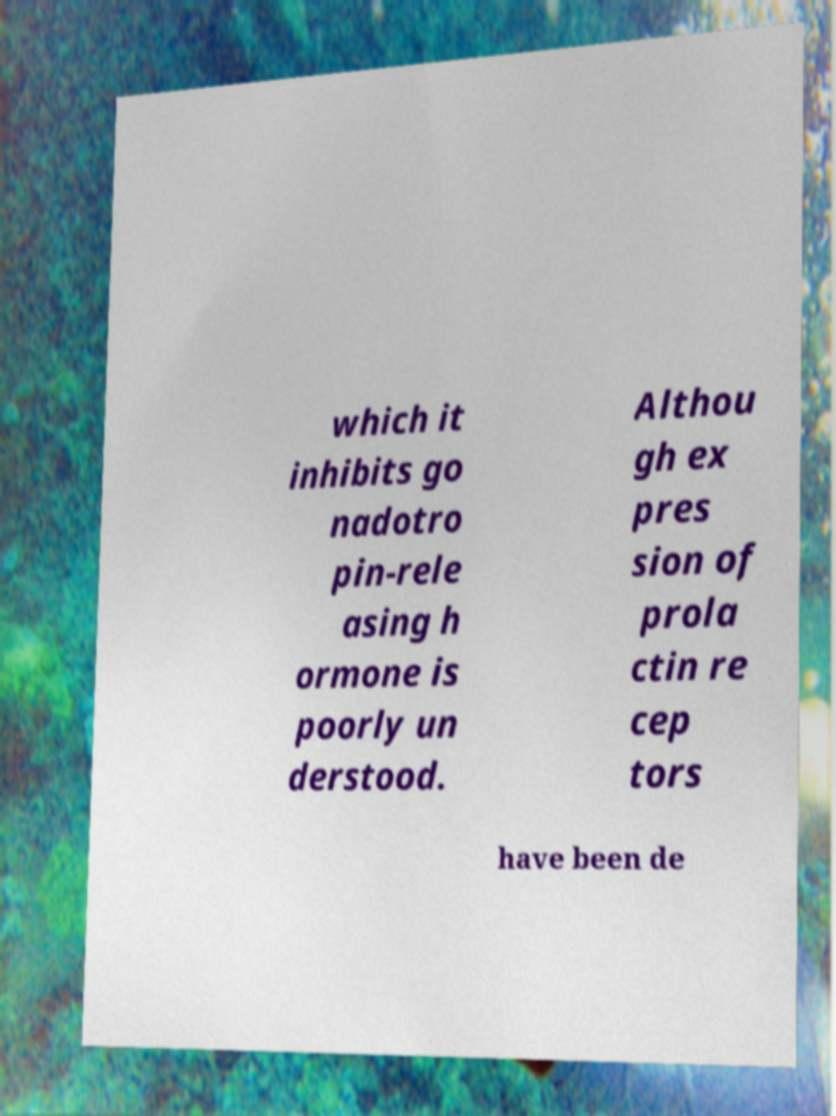Could you assist in decoding the text presented in this image and type it out clearly? which it inhibits go nadotro pin-rele asing h ormone is poorly un derstood. Althou gh ex pres sion of prola ctin re cep tors have been de 